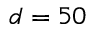Convert formula to latex. <formula><loc_0><loc_0><loc_500><loc_500>d = 5 0</formula> 